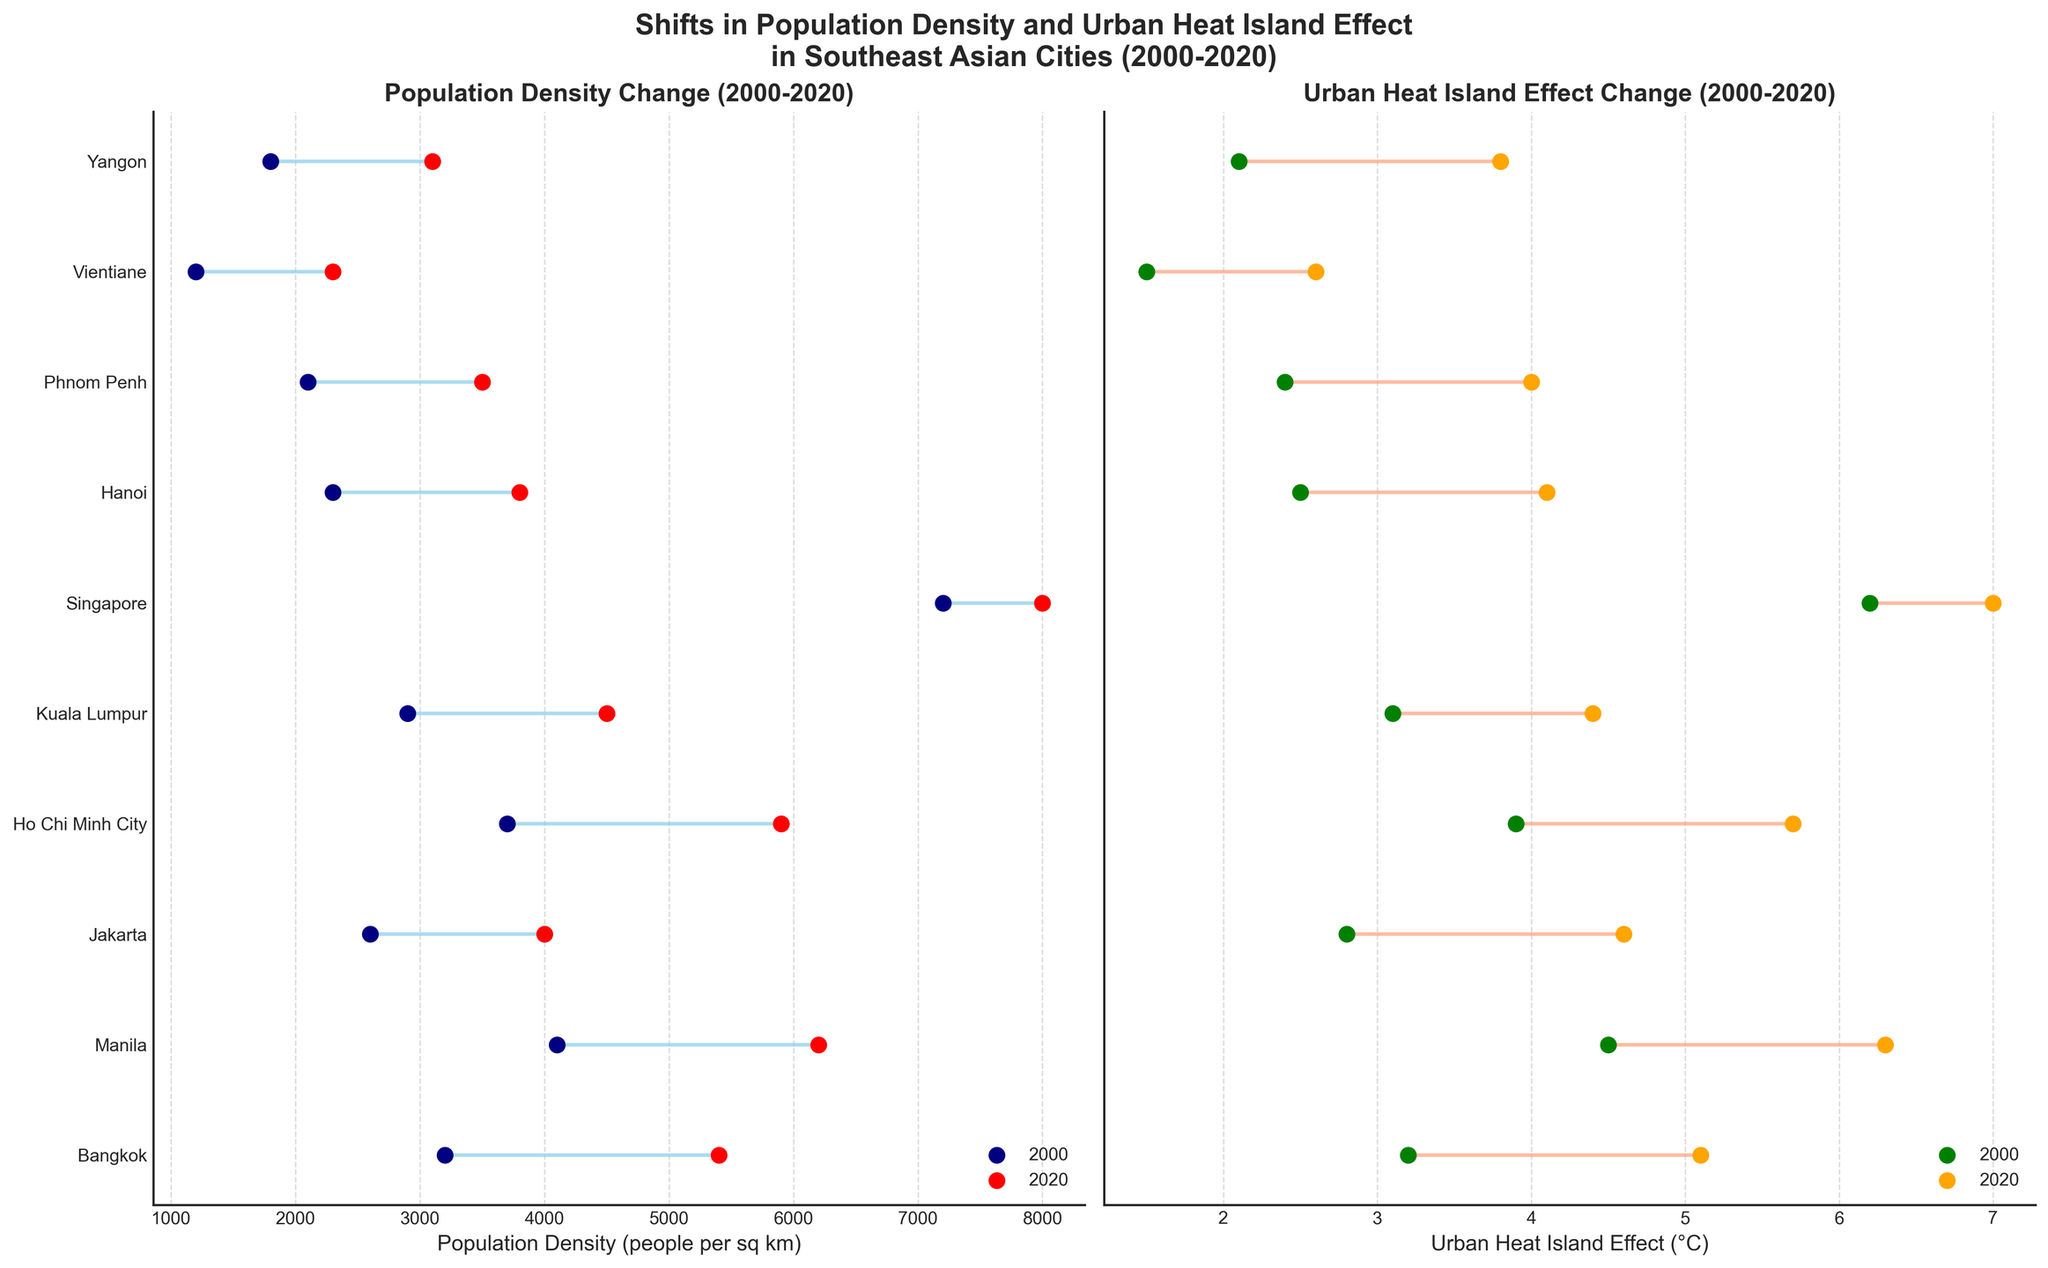What is the title of the plot? The title of the plot is usually found at the top center of the figure. In this case, it is "Shifts in Population Density and Urban Heat Island Effect in Southeast Asian Cities (2000-2020)."
Answer: Shifts in Population Density and Urban Heat Island Effect in Southeast Asian Cities (2000-2020) Which city experienced the greatest increase in population density from 2000 to 2020? To determine this, we need to compare the differences in population density for each city between 2000 and 2020. The difference for each city is calculated by subtracting the 2000 value from the 2020 value. The city with the greatest difference is Ho Chi Minh City with an increase of 2200 people per sq km (5900 - 3700).
Answer: Ho Chi Minh City Which city had the highest Urban Heat Island Effect in 2020? To find the city with the highest Urban Heat Island Effect in 2020, look at the endpoints of the dumbbells on the right plot corresponding to 2020. The highest value is 7.0 °C for Singapore.
Answer: Singapore What was the Urban Heat Island Effect increase in Manila from 2000 to 2020? The increase in Urban Heat Island Effect for Manila is calculated by subtracting the 2000 value from the 2020 value: 6.3 - 4.5 = 1.8 °C.
Answer: 1.8 °C Compare the Population Density change between Bangkok and Jakarta from 2000 to 2020. Which city saw a greater change? Calculate the population density change for both cities. Bangkok's change is 5400 - 3200 = 2200 people per sq km. Jakarta's change is 4000 - 2600 = 1400 people per sq km. Bangkok saw a greater change.
Answer: Bangkok Which city had the lowest Urban Heat Island Effect in 2000 and what was its value? The lowest Urban Heat Island Effect in 2000 is identified by finding the smallest value of all the leftmost data points in the right plot. Vientiane had the lowest value at 1.5 °C.
Answer: Vientiane, 1.5 °C What is the average increase in Population Density for all cities combined from 2000 to 2020? To find the average increase, first calculate the increase for each city, sum them up, and then divide by the number of cities. The increases are: 2200 (Bangkok), 2100 (Manila), 1400 (Jakarta), 2200 (Ho Chi Minh City), 1600 (Kuala Lumpur), 800 (Singapore), 1500 (Hanoi), 1400 (Phnom Penh), 1100 (Vientiane), and 1300 (Yangon). Total increase = 17800. There are 10 cities: 17800/10 = 1780.
Answer: 1780 Is there a city where both Population Density and Urban Heat Island Effect values are the same in 2000 and 2020? Inspect both plots and compare the values at both ends of each city's dumbbells. There is no city where the Population Density and Urban Heat Island Effect values remained the same from 2000 to 2020.
Answer: No 